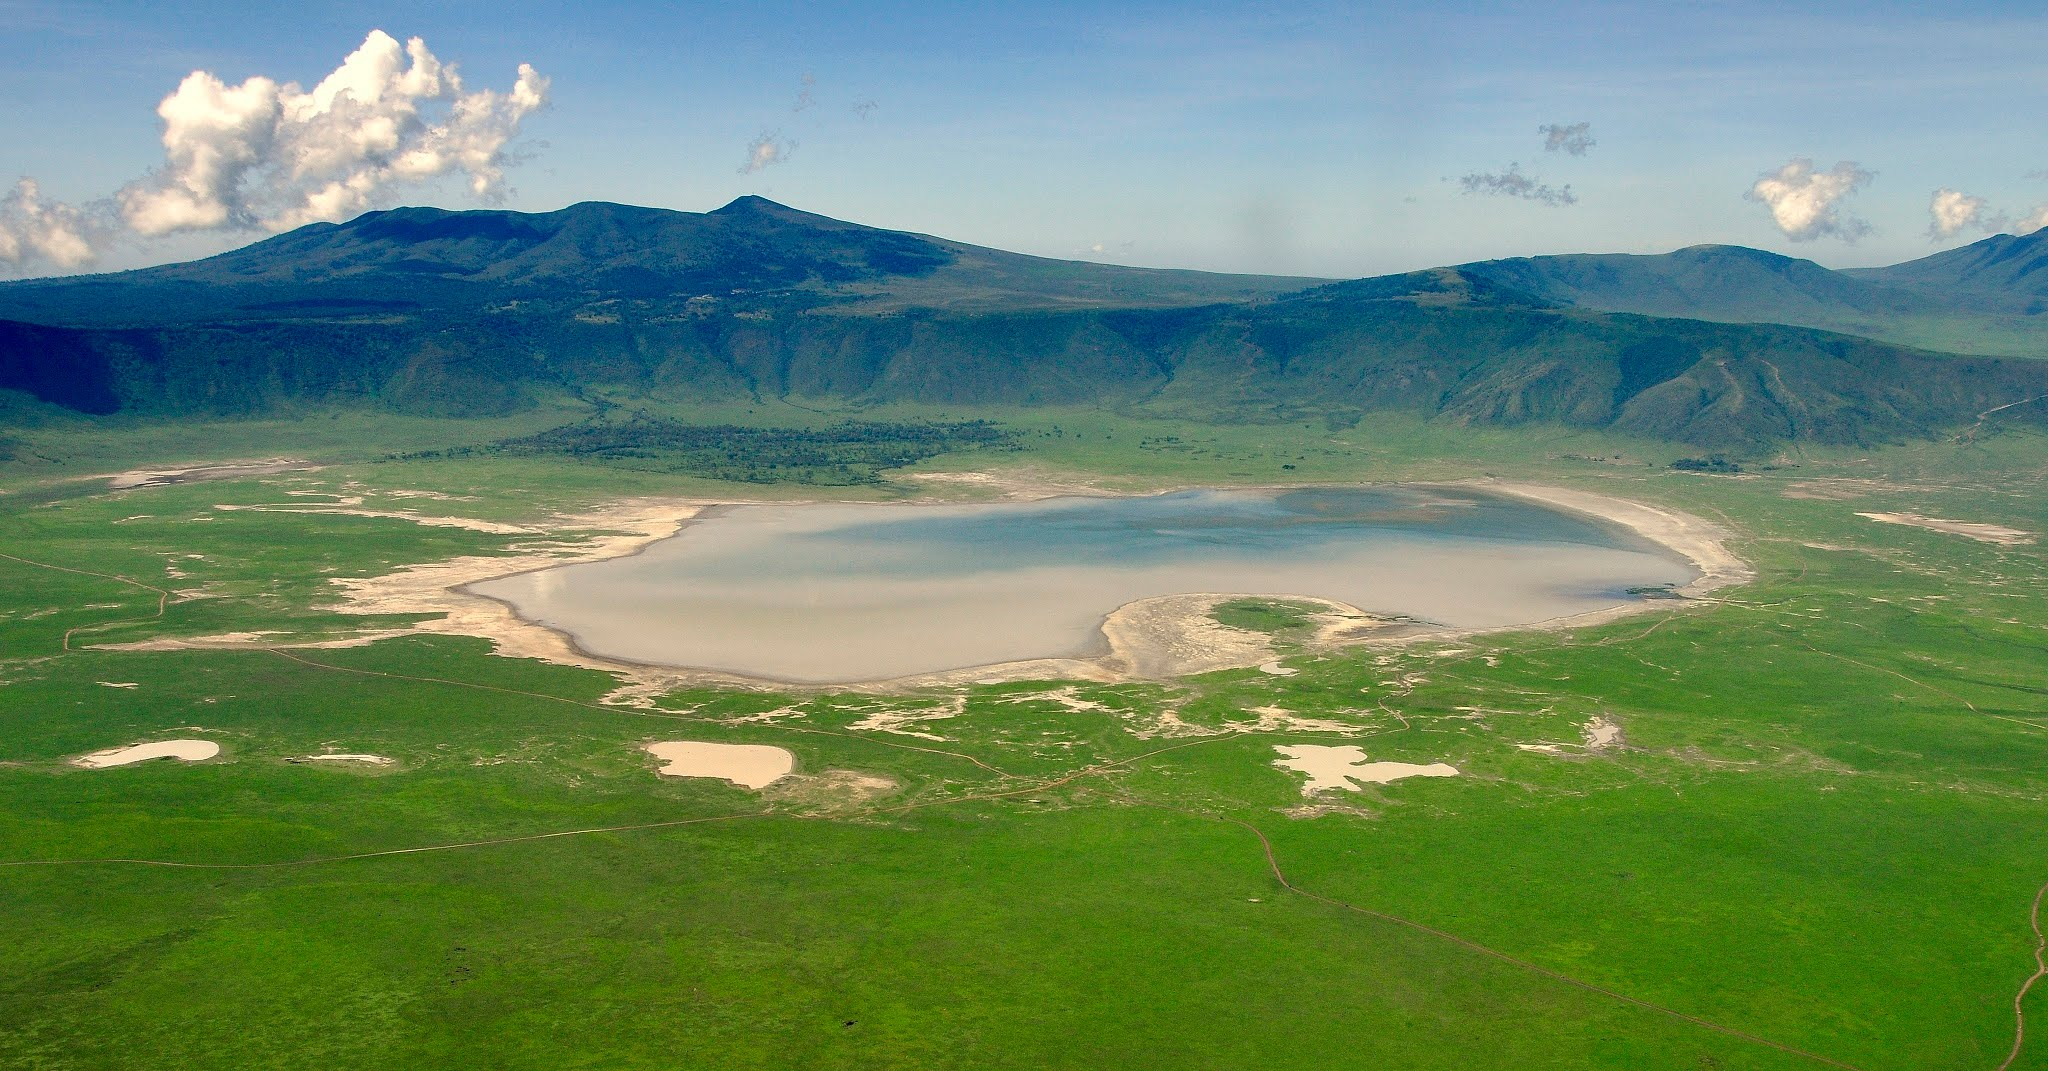Could you explain the geological formation of the Ngorongoro Crater? The Ngorongoro Crater was formed millions of years ago through volcanic activity. It originated from a massive volcano that once stood in northern Tanzania, estimated to be about 14,800 to 9,500 years old. After erupting, the volcano collapsed inward on itself, creating the world’s largest intact volcanic caldera. The resulting caldera measures approximately 20 kilometers in diameter and some 600 meters deep. Over the millennia, erosion and weathering have smoothed the crater's edges and created a diverse landscape within it, including grassy plains, a central lake, and areas of acacia woodland. This geological marvel has created a unique environment that supports a wide range of flora and fauna, making it a significant ecological and geological site. How would the crater have looked during an eruption? During an eruption, the Ngorongoro Volcano would have presented a dramatic and fearsome spectacle. Imagine a towering peak spewing molten lava into the sky, accompanied by a thunderous roar. Ash clouds would have billowed out, darkening the sky and spreading across vast distances. Rivers of glowing lava would have flowed down the slopes, incinerating everything in their path and creating new landforms as they cooled and solidified. Explosions would have ejected rocks and boulders, and toxic gases would have permeated the air. The landscape within the crater would be utterly transformed, with previously verdant areas buried under lava and ash. Over time, as the eruptions subsided, the collapsed caldera began its gradual transformation into the lush and vibrant environment we see today. 